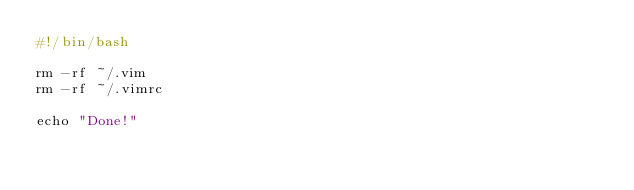<code> <loc_0><loc_0><loc_500><loc_500><_Bash_>#!/bin/bash

rm -rf ~/.vim
rm -rf ~/.vimrc

echo "Done!"

</code> 